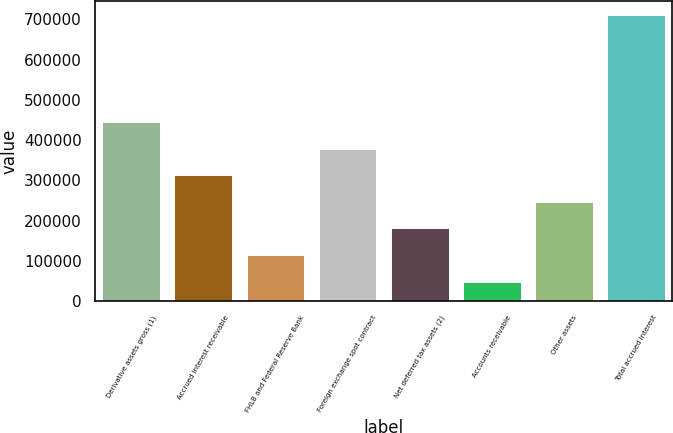<chart> <loc_0><loc_0><loc_500><loc_500><bar_chart><fcel>Derivative assets gross (1)<fcel>Accrued interest receivable<fcel>FHLB and Federal Reserve Bank<fcel>Foreign exchange spot contract<fcel>Net deferred tax assets (2)<fcel>Accounts receivable<fcel>Other assets<fcel>Total accrued interest<nl><fcel>445289<fcel>313080<fcel>114766<fcel>379184<fcel>180871<fcel>48662<fcel>246976<fcel>709707<nl></chart> 